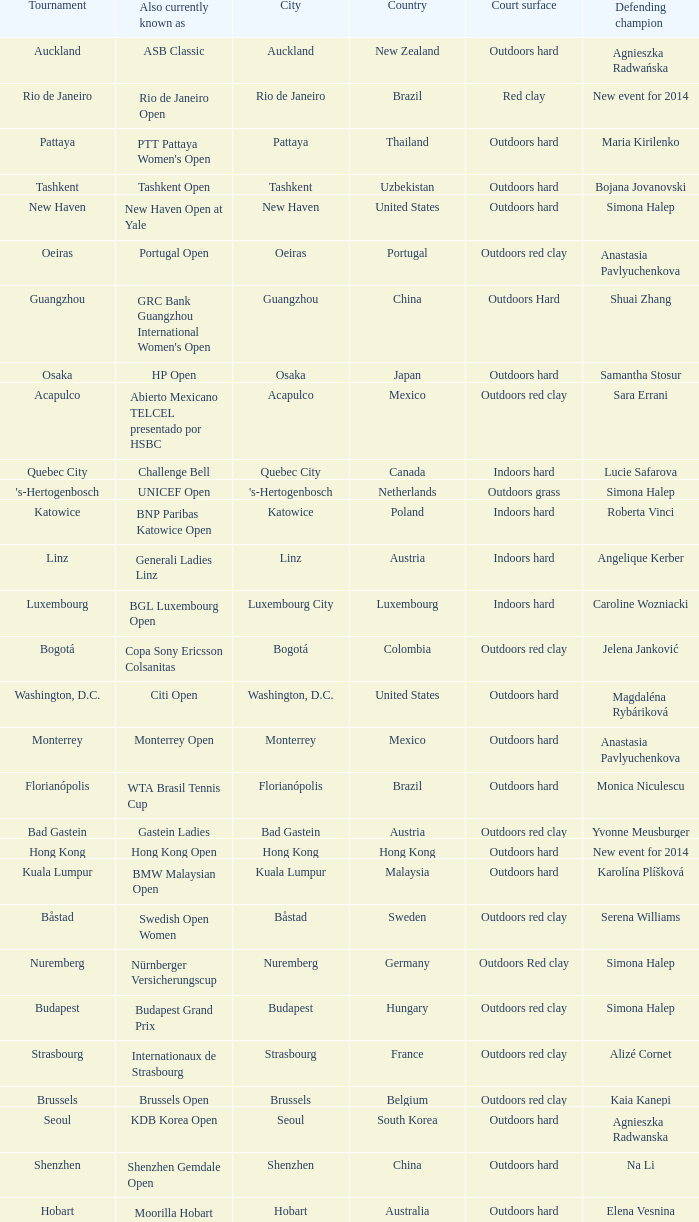What tournament is in katowice? Katowice. 